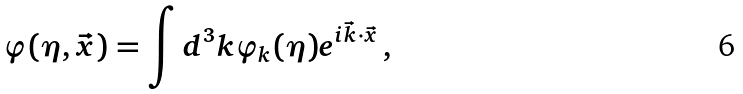<formula> <loc_0><loc_0><loc_500><loc_500>\varphi ( \eta , \vec { x } ) = \int d ^ { 3 } k \varphi _ { k } ( { \eta } ) e ^ { i \vec { k } \cdot \vec { x } } \, ,</formula> 